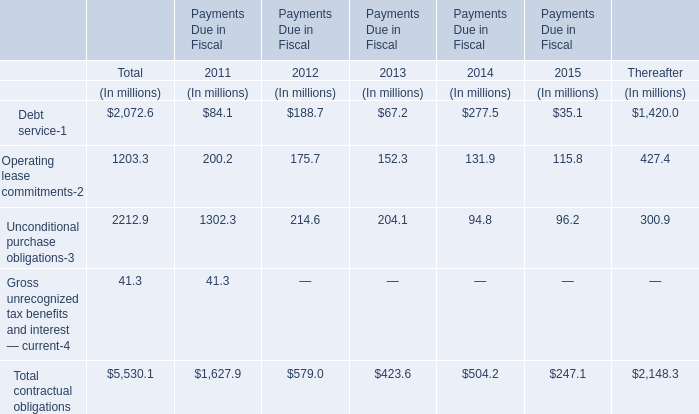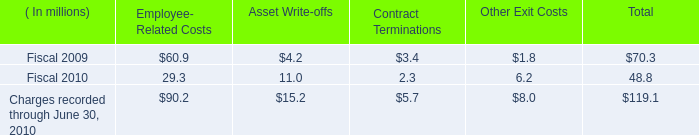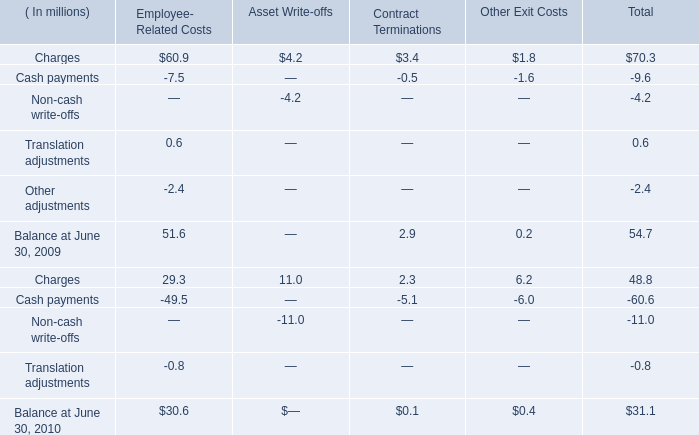What's the increasing rate of Contract Terminations in 2010? (in million) 
Computations: ((2.3 - 3.4) / 3.4)
Answer: -0.32353. 